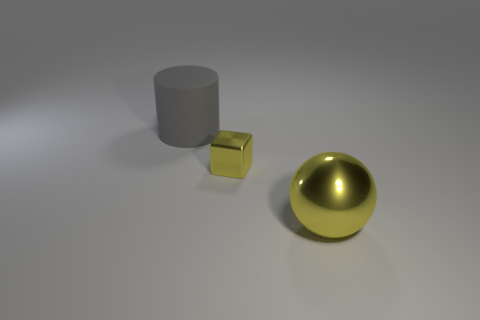What materials do these objects appear to be made of? The objects in the image seem to be made of different materials. The gray cylinder looks like it could be made of a matte substance such as concrete or stone, the small cube has a metallic texture that suggests it could be gold or brass, and the shiny sphere has a reflective surface indicative of polished metal or glass. 